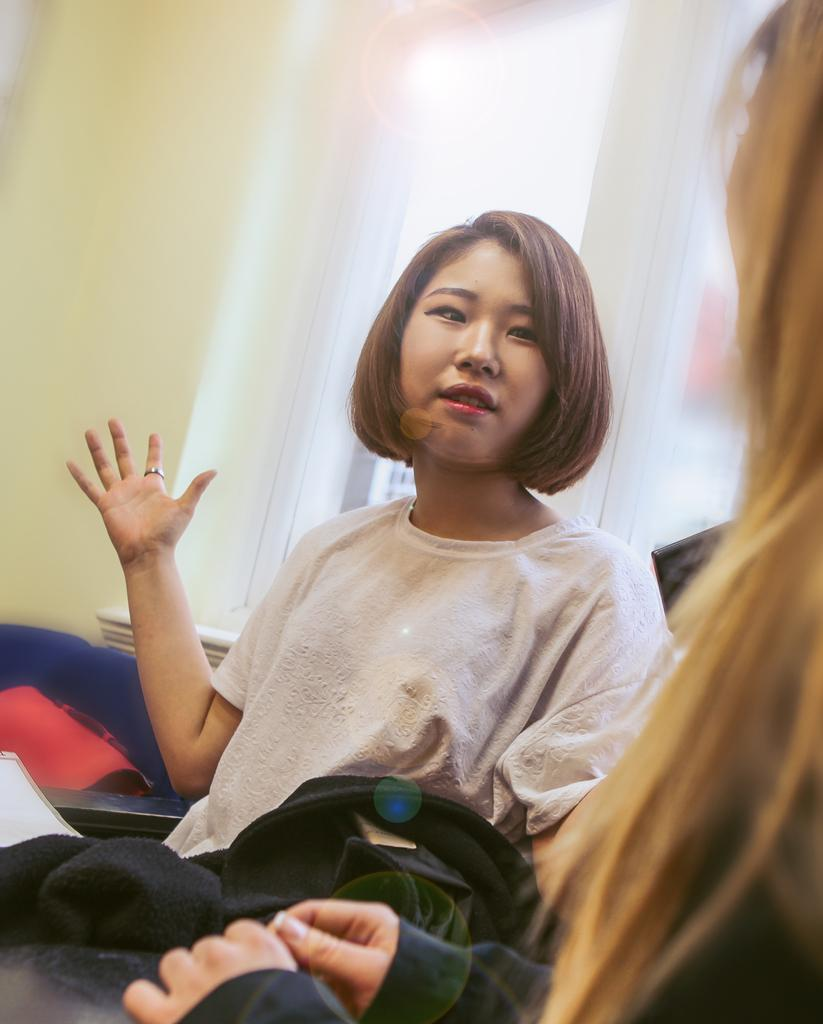How many women are in the room? There are 2 women in the room. What is one of the women wearing? One of the women is wearing a white t-shirt. Is there any source of natural light in the room? Yes, there is a window in the room. What type of berry can be seen on the tramp in the room? There is no tramp or berry present in the room; the image only features two women and a window. 